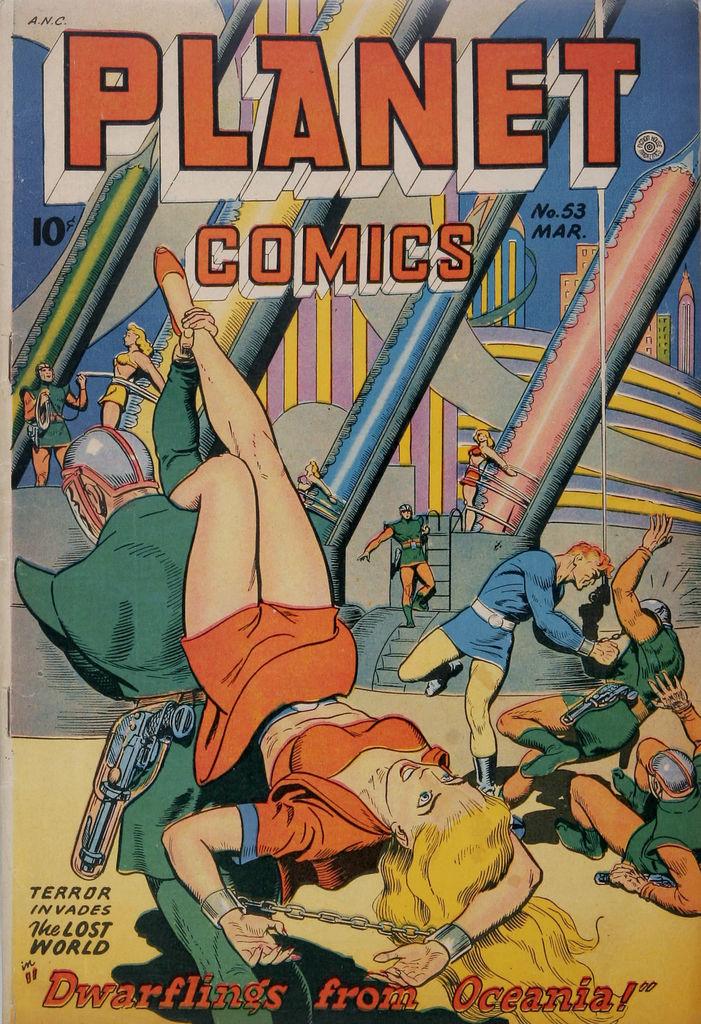What number is this comic?
Keep it short and to the point. 53. What is the title of the comic book?
Give a very brief answer. Planet comics. 